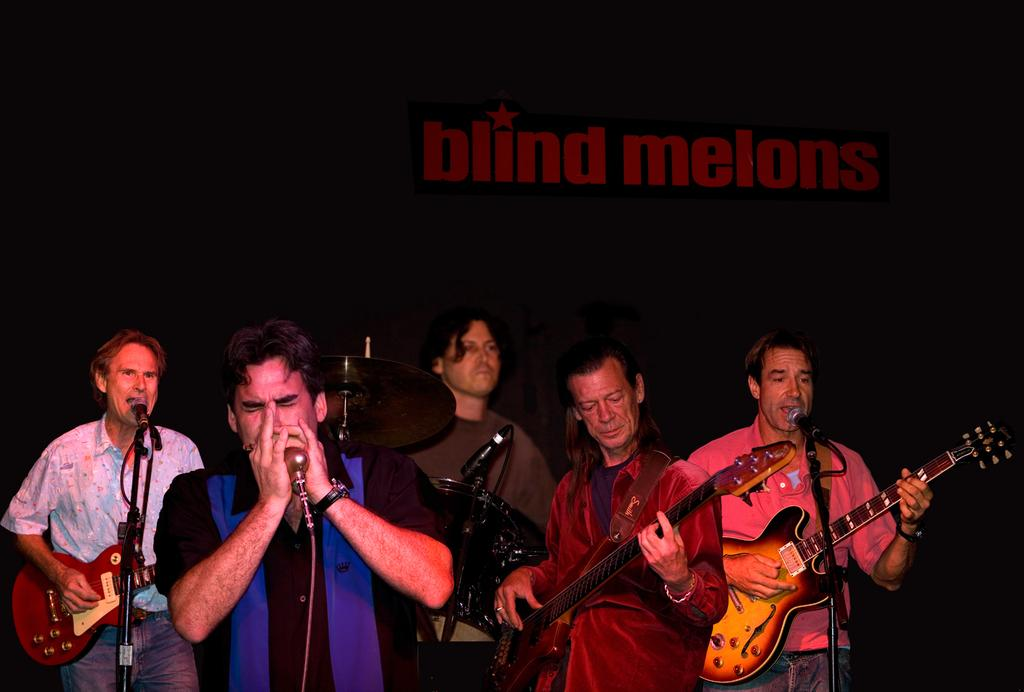What are the persons in the image doing? The persons in the image are playing musical instruments. Can you describe the activity of the two persons in front of the microphone? The two persons in front of the microphone are singing. Where can the sink be found in the image? There is no sink present in the image. What type of balls are being used by the persons playing musical instruments? The persons playing musical instruments are not using any balls; they are playing instruments and singing. 